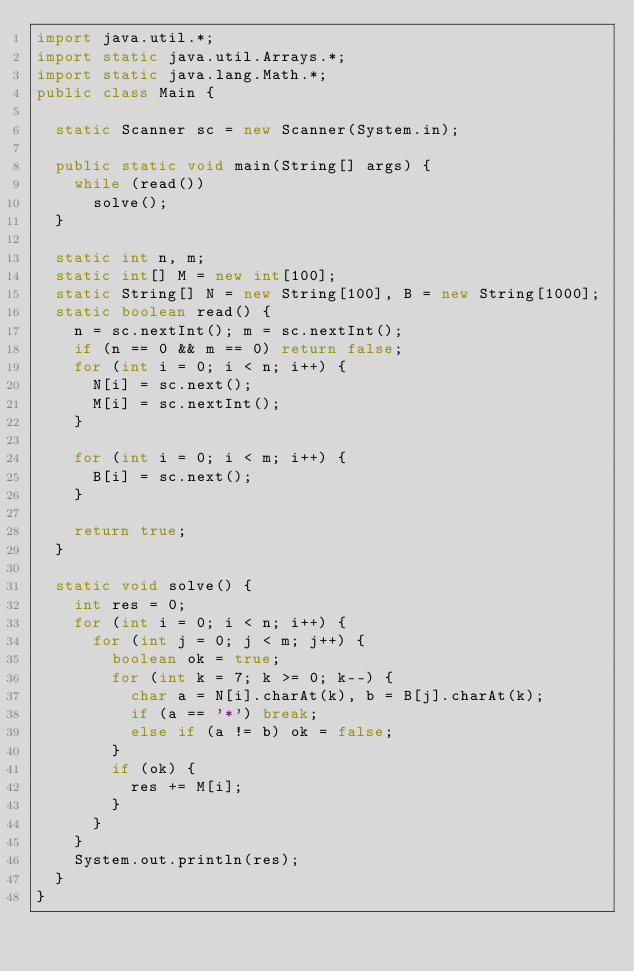Convert code to text. <code><loc_0><loc_0><loc_500><loc_500><_Java_>import java.util.*;
import static java.util.Arrays.*;
import static java.lang.Math.*;
public class Main {

	static Scanner sc = new Scanner(System.in);
	
	public static void main(String[] args) {
		while (read())
			solve();
	}
	
	static int n, m;
	static int[] M = new int[100];
	static String[] N = new String[100], B = new String[1000];
	static boolean read() {
		n = sc.nextInt(); m = sc.nextInt();
		if (n == 0 && m == 0) return false;
		for (int i = 0; i < n; i++) {
			N[i] = sc.next();
			M[i] = sc.nextInt();
		}
	
		for (int i = 0; i < m; i++) {
			B[i] = sc.next();
		}
		
		return true;
	}
	
	static void solve() {
		int res = 0;
		for (int i = 0; i < n; i++) {
			for (int j = 0; j < m; j++) {
				boolean ok = true;
				for (int k = 7; k >= 0; k--) {
					char a = N[i].charAt(k), b = B[j].charAt(k);
					if (a == '*') break;
					else if (a != b) ok = false;
				}
				if (ok) {
					res += M[i];
				}
			}
		}
		System.out.println(res);
	}
}</code> 